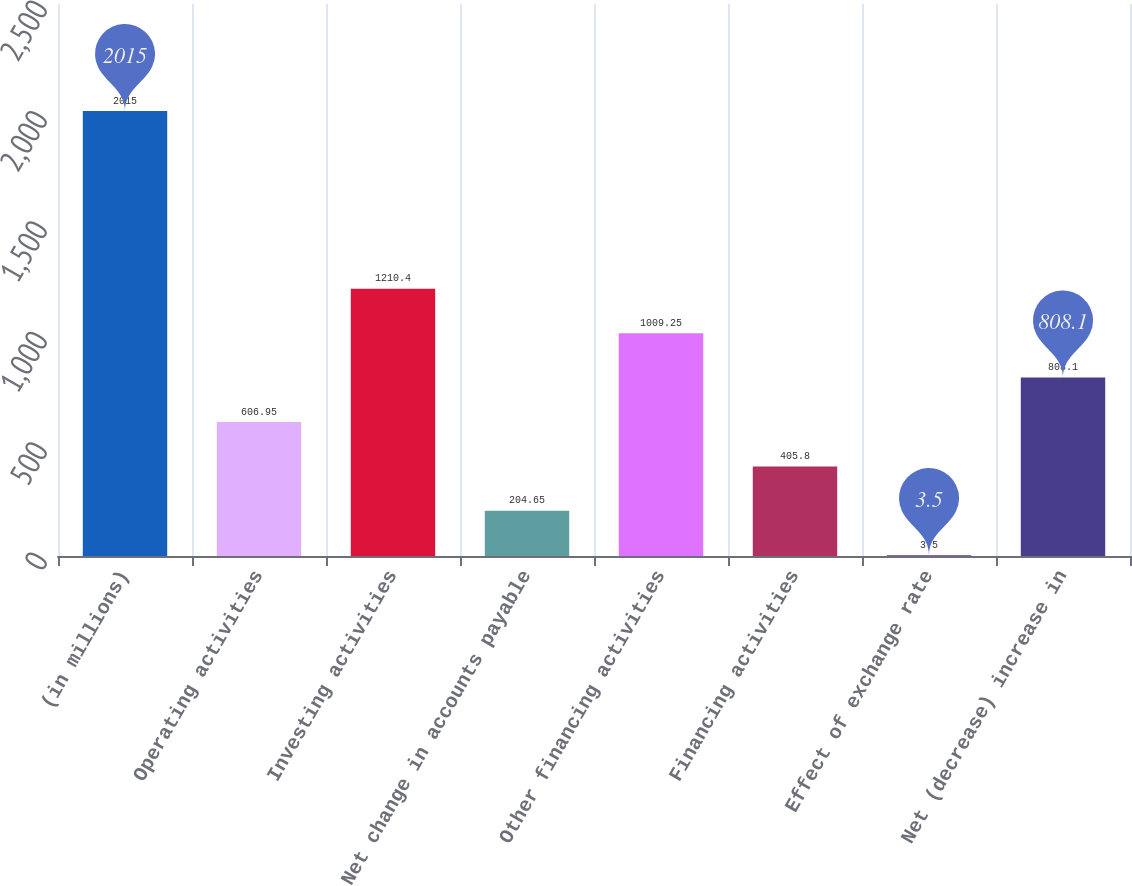Convert chart to OTSL. <chart><loc_0><loc_0><loc_500><loc_500><bar_chart><fcel>(in millions)<fcel>Operating activities<fcel>Investing activities<fcel>Net change in accounts payable<fcel>Other financing activities<fcel>Financing activities<fcel>Effect of exchange rate<fcel>Net (decrease) increase in<nl><fcel>2015<fcel>606.95<fcel>1210.4<fcel>204.65<fcel>1009.25<fcel>405.8<fcel>3.5<fcel>808.1<nl></chart> 